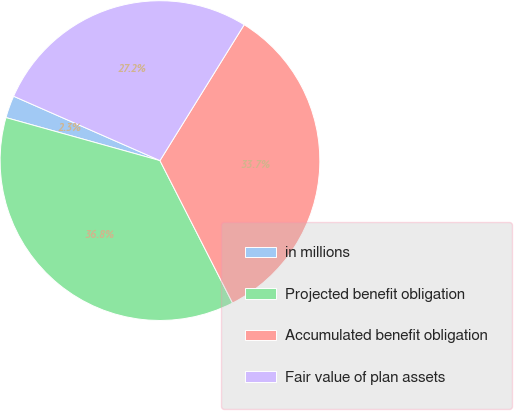Convert chart. <chart><loc_0><loc_0><loc_500><loc_500><pie_chart><fcel>in millions<fcel>Projected benefit obligation<fcel>Accumulated benefit obligation<fcel>Fair value of plan assets<nl><fcel>2.26%<fcel>36.84%<fcel>33.67%<fcel>27.24%<nl></chart> 